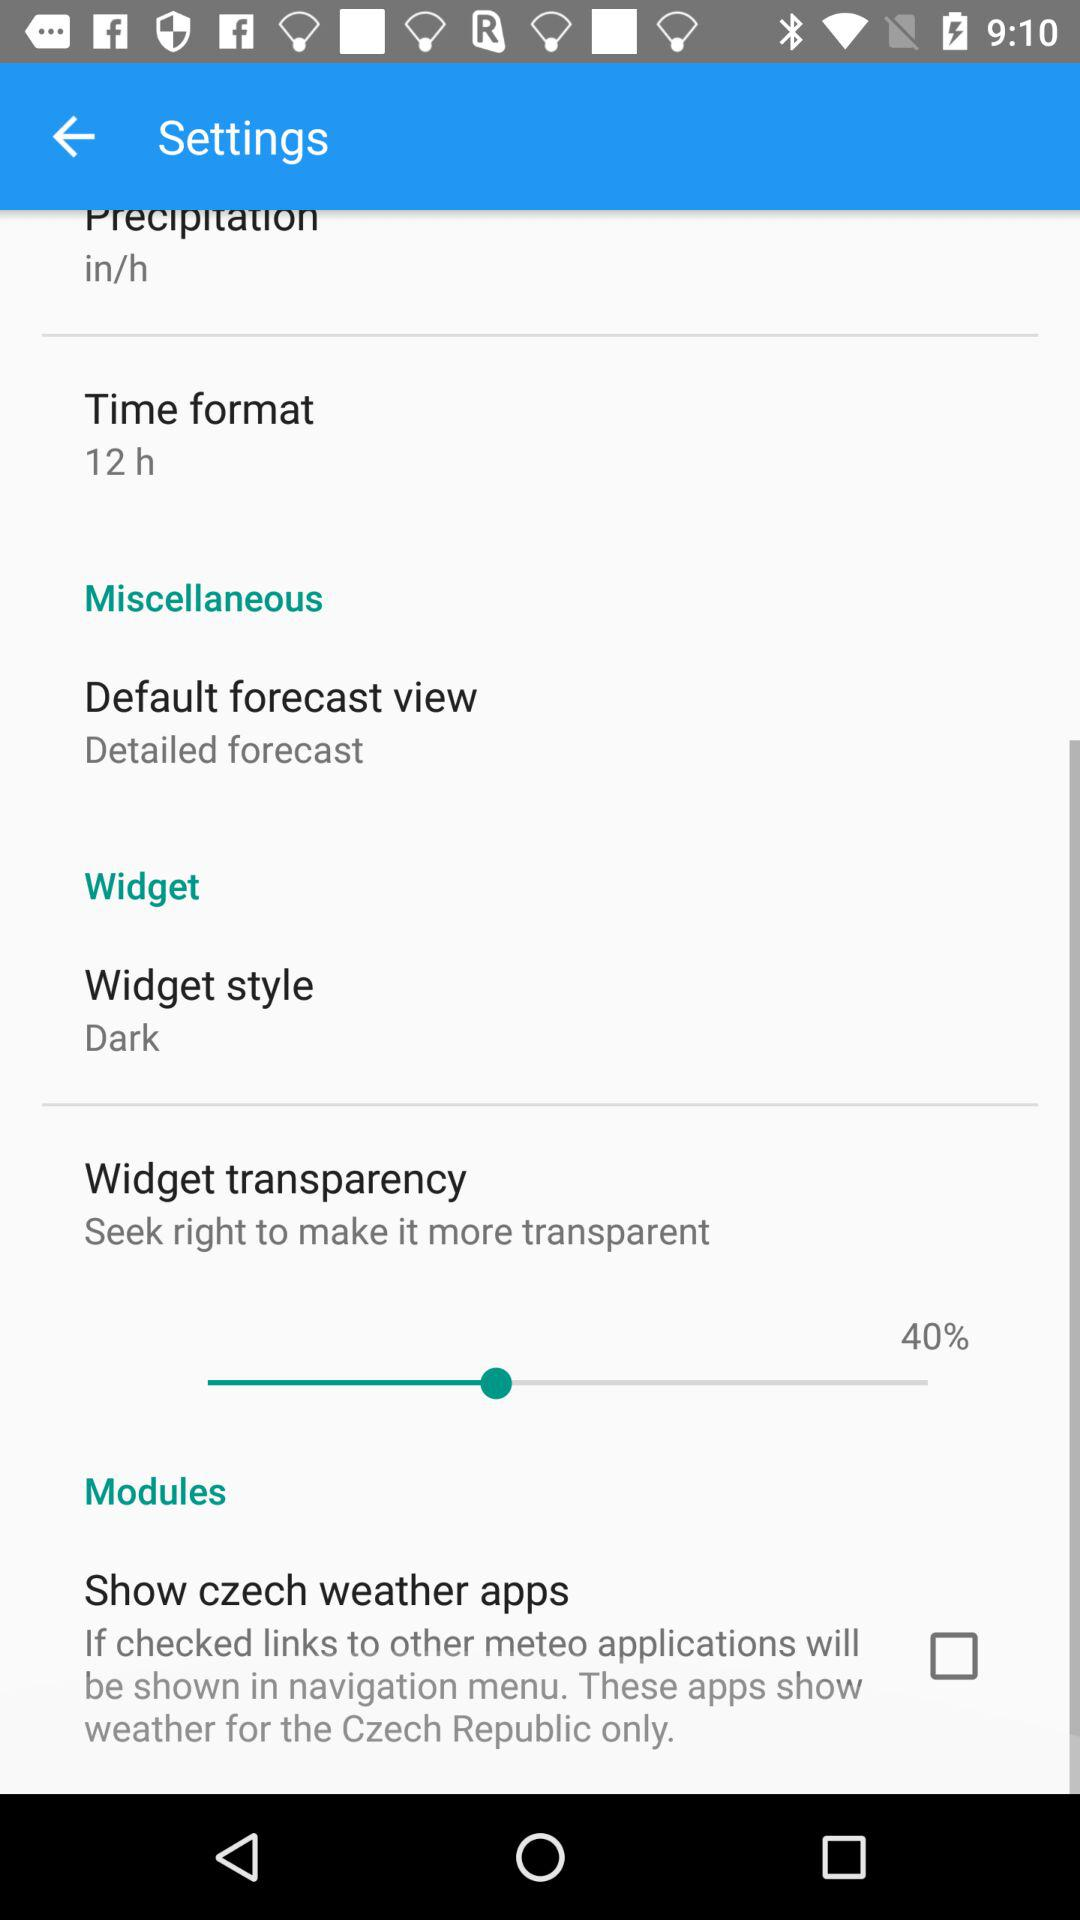What is the widget transparency percentage? The widget transparency percentage is 40. 